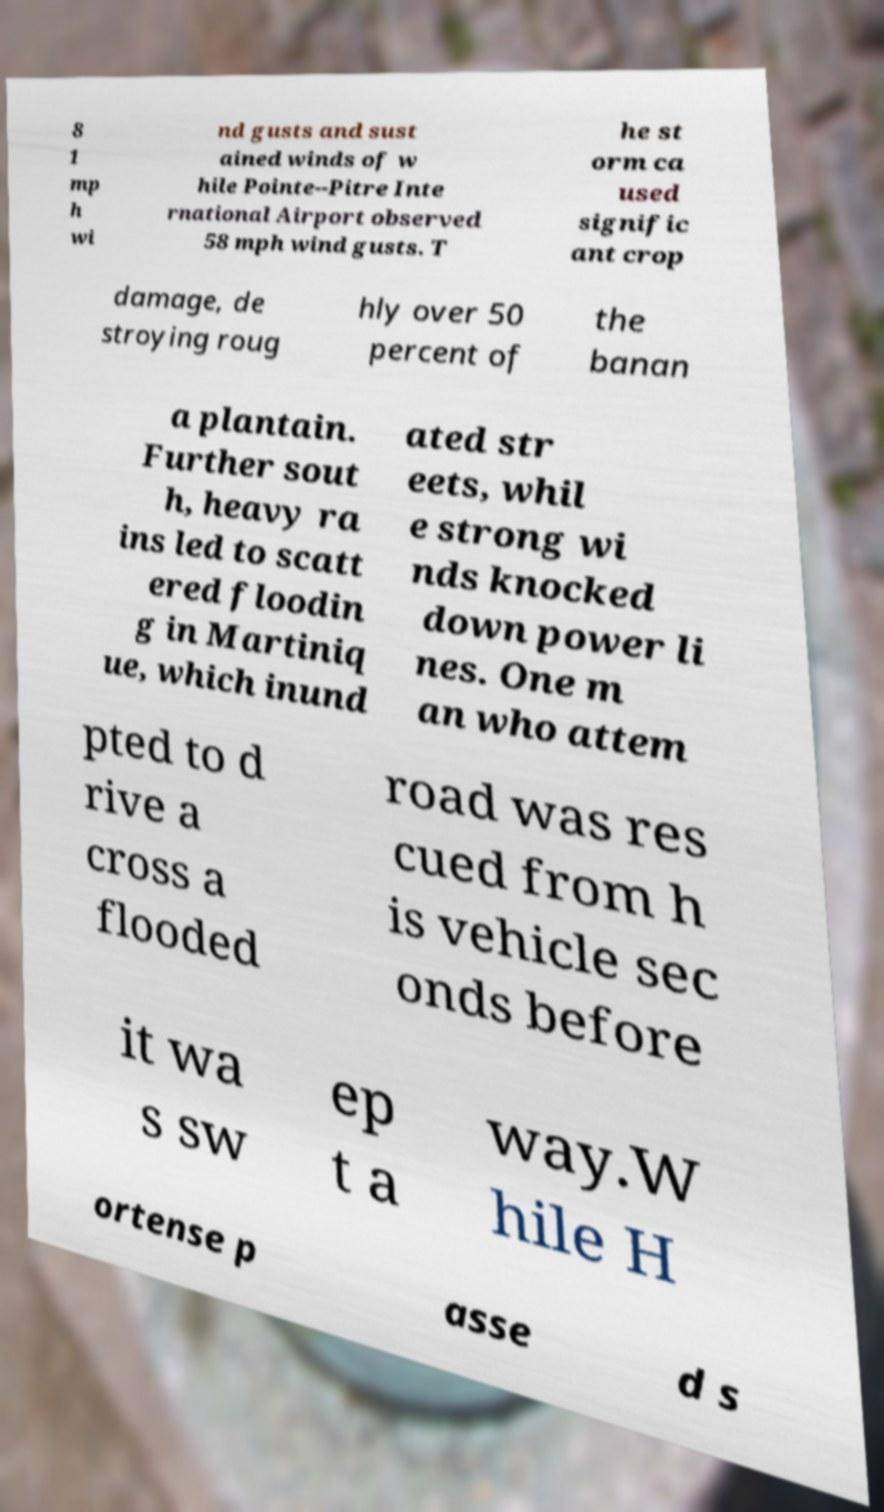There's text embedded in this image that I need extracted. Can you transcribe it verbatim? 8 1 mp h wi nd gusts and sust ained winds of w hile Pointe--Pitre Inte rnational Airport observed 58 mph wind gusts. T he st orm ca used signific ant crop damage, de stroying roug hly over 50 percent of the banan a plantain. Further sout h, heavy ra ins led to scatt ered floodin g in Martiniq ue, which inund ated str eets, whil e strong wi nds knocked down power li nes. One m an who attem pted to d rive a cross a flooded road was res cued from h is vehicle sec onds before it wa s sw ep t a way.W hile H ortense p asse d s 